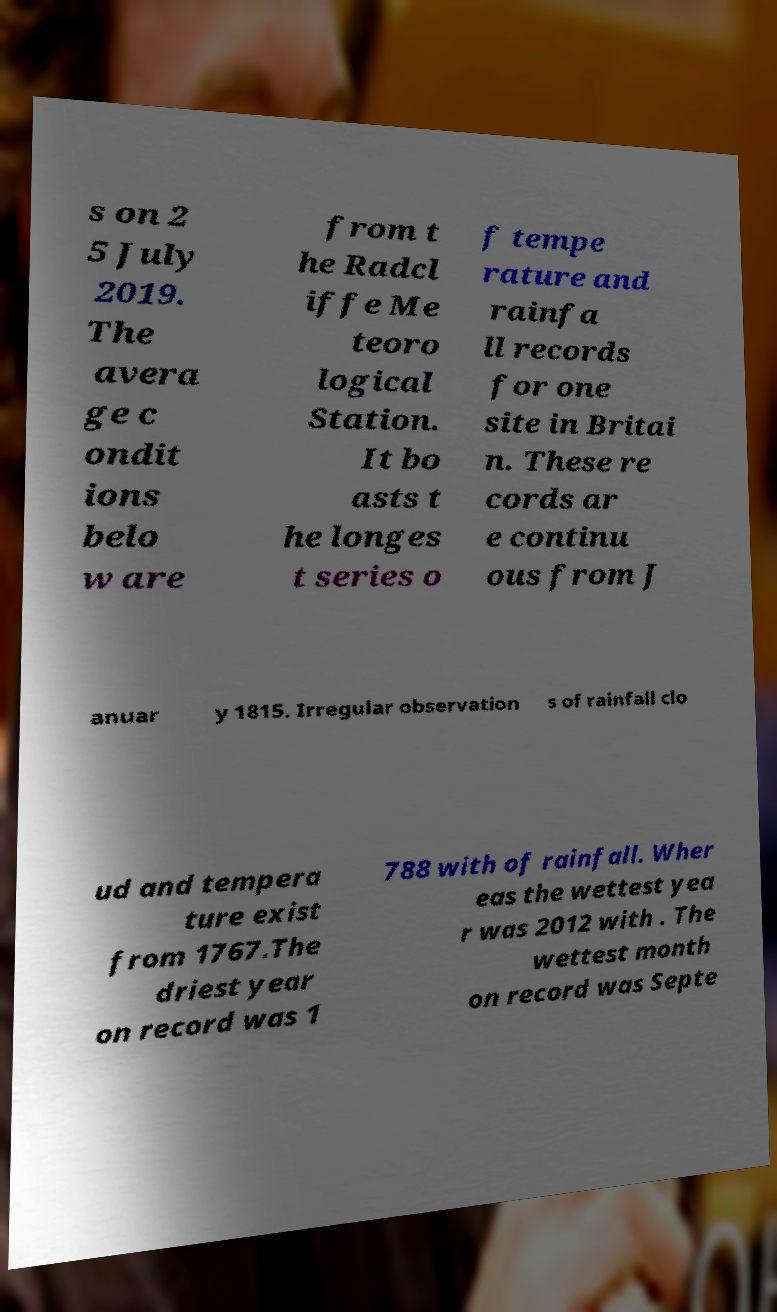Can you read and provide the text displayed in the image?This photo seems to have some interesting text. Can you extract and type it out for me? s on 2 5 July 2019. The avera ge c ondit ions belo w are from t he Radcl iffe Me teoro logical Station. It bo asts t he longes t series o f tempe rature and rainfa ll records for one site in Britai n. These re cords ar e continu ous from J anuar y 1815. Irregular observation s of rainfall clo ud and tempera ture exist from 1767.The driest year on record was 1 788 with of rainfall. Wher eas the wettest yea r was 2012 with . The wettest month on record was Septe 